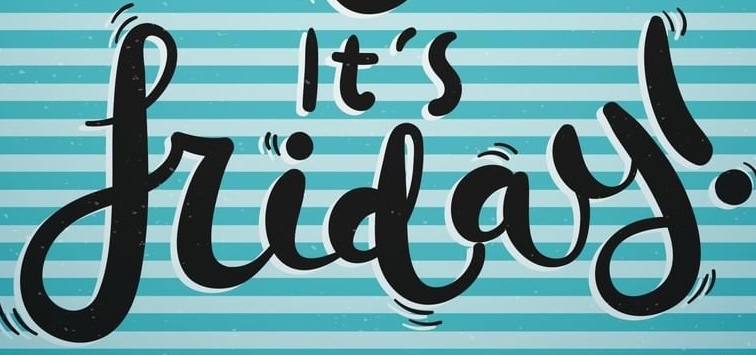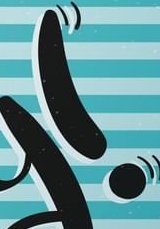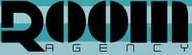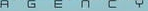Read the text content from these images in order, separated by a semicolon. friday; !; ROOM; AGENCY 